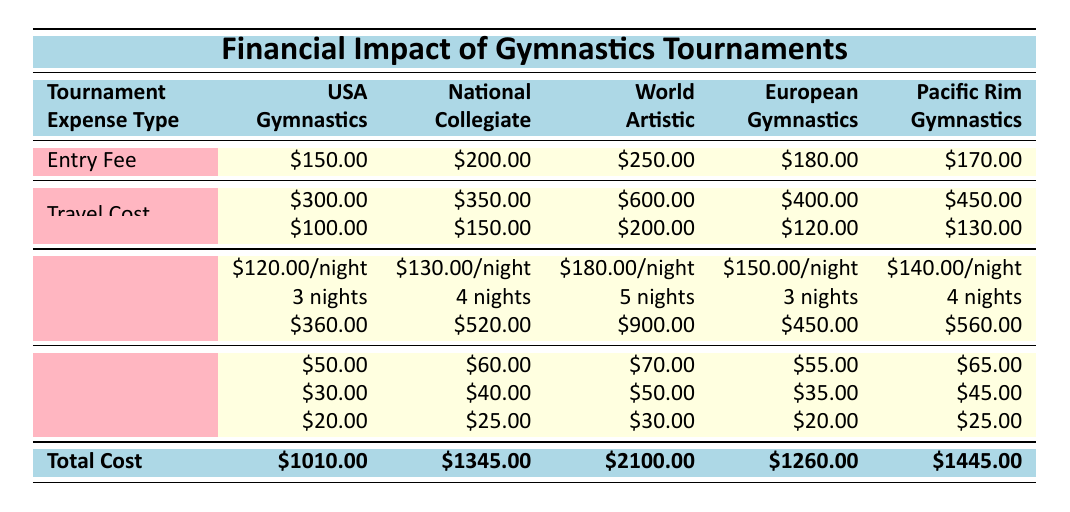What is the entry fee for the World Artistic Gymnastics Championships? The table clearly shows under the "Entry Fee" row for the "World" column that the entry fee is $250.00.
Answer: 250 What is the total cost to participate in the National Collegiate Gymnastics Championships? The "Total Cost" row for the "National" column indicates that the total cost is $1345.00.
Answer: 1345 Is the accommodation cost for the European Gymnastics Championships lower than that of the USA Gymnastics Championships? The total accommodation cost for the European tournament is $450.00 while for the USA tournament, it is $360.00; therefore, $450.00 is higher.
Answer: No What is the average entry fee across all tournaments? The entry fees are $150.00, $200.00, $250.00, $180.00, and $170.00. Summing these gives: 150 + 200 + 250 + 180 + 170 = 1030. Dividing this sum by 5 gives: 1030 / 5 = 206.
Answer: 206 Which tournament has the highest total cost? The total costs are as follows: USA $1010, National $1345, World $2100, European $1260, and Pacific Rim $1445. The highest among these values is $2100 for the World tournament.
Answer: World Artistic Gymnastics Championships How much more is the travel cost for the World Artistic Gymnastics Championships than that for the USA Gymnastics Championships? The travel cost for the World tournament is $600.00, while for the USA tournament it is $300.00. The difference is $600 - $300 = $300.
Answer: 300 Does the total accommodation cost for the Pacific Rim Gymnastics Championships exceed $500? The total accommodation cost for the Pacific Rim is $560.00, which is higher than $500.
Answer: Yes What are the total other expenses for the European Gymnastics Championships? The other expenses for the European tournament are $55.00 (food) + $35.00 (transportation) + $20.00 (miscellaneous) which equals $110.00.
Answer: 110 What is the total cost for the Pacific Rim Gymnastics Championships minus the entry fee? The total cost is $1445.00. Subtracting the entry fee of $170.00 gives: $1445 - $170 = $1275.
Answer: 1275 